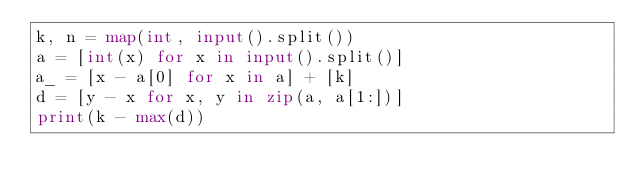<code> <loc_0><loc_0><loc_500><loc_500><_Python_>k, n = map(int, input().split())
a = [int(x) for x in input().split()]
a_ = [x - a[0] for x in a] + [k]
d = [y - x for x, y in zip(a, a[1:])]
print(k - max(d))</code> 